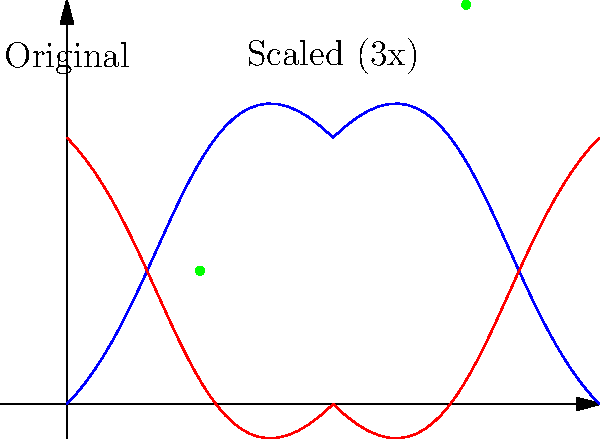A diagram of a DNA strand shows a genetic mutation at coordinates $(0.5, 0.5)$. If the diagram is scaled up by a factor of 3 to better visualize the mutation, what will be the new coordinates of the mutation point? Consider the potential impact of such scaling on the accuracy of genetic analysis and its implications for medical malpractice cases. To solve this problem, we need to apply the concept of scaling in transformational geometry. When an object is scaled by a factor $k$, its coordinates are multiplied by that factor. In this case, the scaling factor is 3.

Step 1: Identify the original coordinates of the mutation point.
Original coordinates: $(0.5, 0.5)$

Step 2: Apply the scaling factor to both x and y coordinates.
New x-coordinate = $0.5 * 3 = 1.5$
New y-coordinate = $0.5 * 3 = 1.5$

Step 3: Write the new coordinates as an ordered pair.
New coordinates: $(1.5, 1.5)$

In the context of medical practice and potential malpractice cases, it's important to note that while scaling can help visualize genetic mutations, it's crucial to maintain accurate records of the original data. Misinterpretation of scaled diagrams could lead to errors in genetic analysis, potentially resulting in misdiagnosis or improper treatment. This underscores the importance of clear documentation and communication in medical practice to minimize the risk of malpractice claims, which can contribute to rising healthcare costs.
Answer: $(1.5, 1.5)$ 